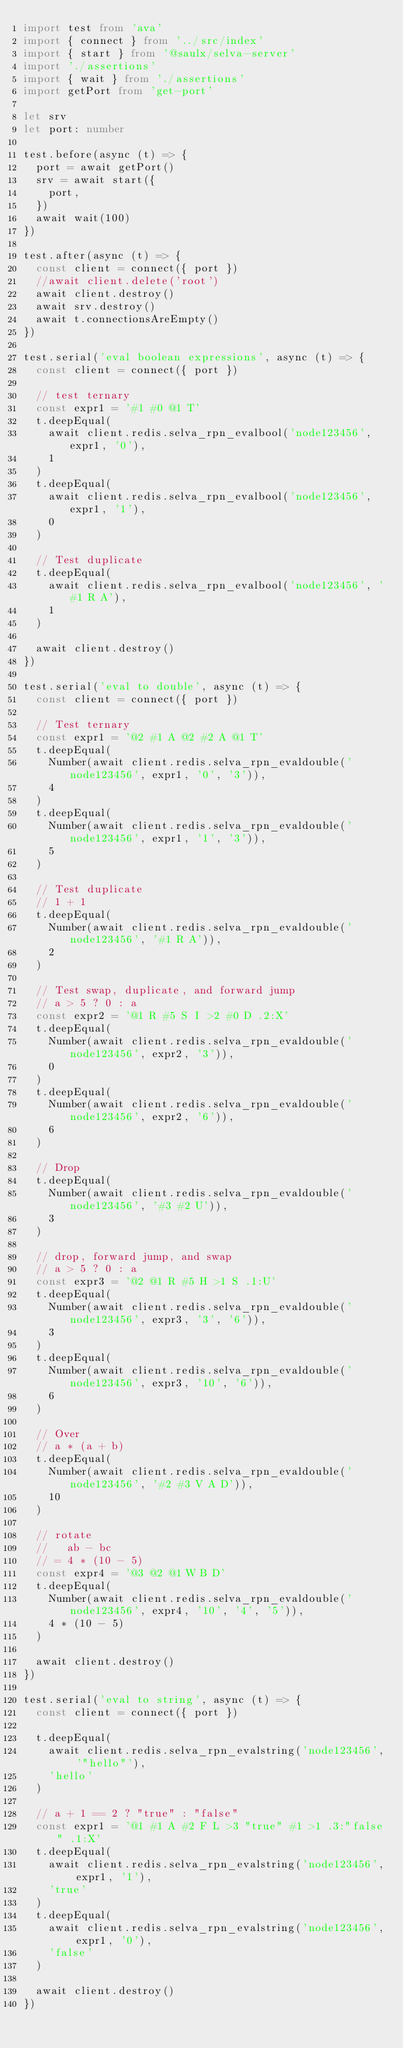Convert code to text. <code><loc_0><loc_0><loc_500><loc_500><_TypeScript_>import test from 'ava'
import { connect } from '../src/index'
import { start } from '@saulx/selva-server'
import './assertions'
import { wait } from './assertions'
import getPort from 'get-port'

let srv
let port: number

test.before(async (t) => {
  port = await getPort()
  srv = await start({
    port,
  })
  await wait(100)
})

test.after(async (t) => {
  const client = connect({ port })
  //await client.delete('root')
  await client.destroy()
  await srv.destroy()
  await t.connectionsAreEmpty()
})

test.serial('eval boolean expressions', async (t) => {
  const client = connect({ port })

  // test ternary
  const expr1 = '#1 #0 @1 T'
  t.deepEqual(
    await client.redis.selva_rpn_evalbool('node123456', expr1, '0'),
    1
  )
  t.deepEqual(
    await client.redis.selva_rpn_evalbool('node123456', expr1, '1'),
    0
  )

  // Test duplicate
  t.deepEqual(
    await client.redis.selva_rpn_evalbool('node123456', '#1 R A'),
    1
  )

  await client.destroy()
})

test.serial('eval to double', async (t) => {
  const client = connect({ port })

  // Test ternary
  const expr1 = '@2 #1 A @2 #2 A @1 T'
  t.deepEqual(
    Number(await client.redis.selva_rpn_evaldouble('node123456', expr1, '0', '3')),
    4
  )
  t.deepEqual(
    Number(await client.redis.selva_rpn_evaldouble('node123456', expr1, '1', '3')),
    5
  )

  // Test duplicate
  // 1 + 1
  t.deepEqual(
    Number(await client.redis.selva_rpn_evaldouble('node123456', '#1 R A')),
    2
  )

  // Test swap, duplicate, and forward jump
  // a > 5 ? 0 : a
  const expr2 = '@1 R #5 S I >2 #0 D .2:X'
  t.deepEqual(
    Number(await client.redis.selva_rpn_evaldouble('node123456', expr2, '3')),
    0
  )
  t.deepEqual(
    Number(await client.redis.selva_rpn_evaldouble('node123456', expr2, '6')),
    6
  )

  // Drop
  t.deepEqual(
    Number(await client.redis.selva_rpn_evaldouble('node123456', '#3 #2 U')),
    3
  )

  // drop, forward jump, and swap
  // a > 5 ? 0 : a
  const expr3 = '@2 @1 R #5 H >1 S .1:U'
  t.deepEqual(
    Number(await client.redis.selva_rpn_evaldouble('node123456', expr3, '3', '6')),
    3
  )
  t.deepEqual(
    Number(await client.redis.selva_rpn_evaldouble('node123456', expr3, '10', '6')),
    6
  )

  // Over
  // a * (a + b)
  t.deepEqual(
    Number(await client.redis.selva_rpn_evaldouble('node123456', '#2 #3 V A D')),
    10
  )

  // rotate
  //   ab - bc
  // = 4 * (10 - 5)
  const expr4 = '@3 @2 @1 W B D'
  t.deepEqual(
    Number(await client.redis.selva_rpn_evaldouble('node123456', expr4, '10', '4', '5')),
    4 * (10 - 5)
  )

  await client.destroy()
})

test.serial('eval to string', async (t) => {
  const client = connect({ port })

  t.deepEqual(
    await client.redis.selva_rpn_evalstring('node123456', '"hello"'),
    'hello'
  )

  // a + 1 == 2 ? "true" : "false"
  const expr1 = '@1 #1 A #2 F L >3 "true" #1 >1 .3:"false" .1:X'
  t.deepEqual(
    await client.redis.selva_rpn_evalstring('node123456', expr1, '1'),
    'true'
  )
  t.deepEqual(
    await client.redis.selva_rpn_evalstring('node123456', expr1, '0'),
    'false'
  )

  await client.destroy()
})
</code> 